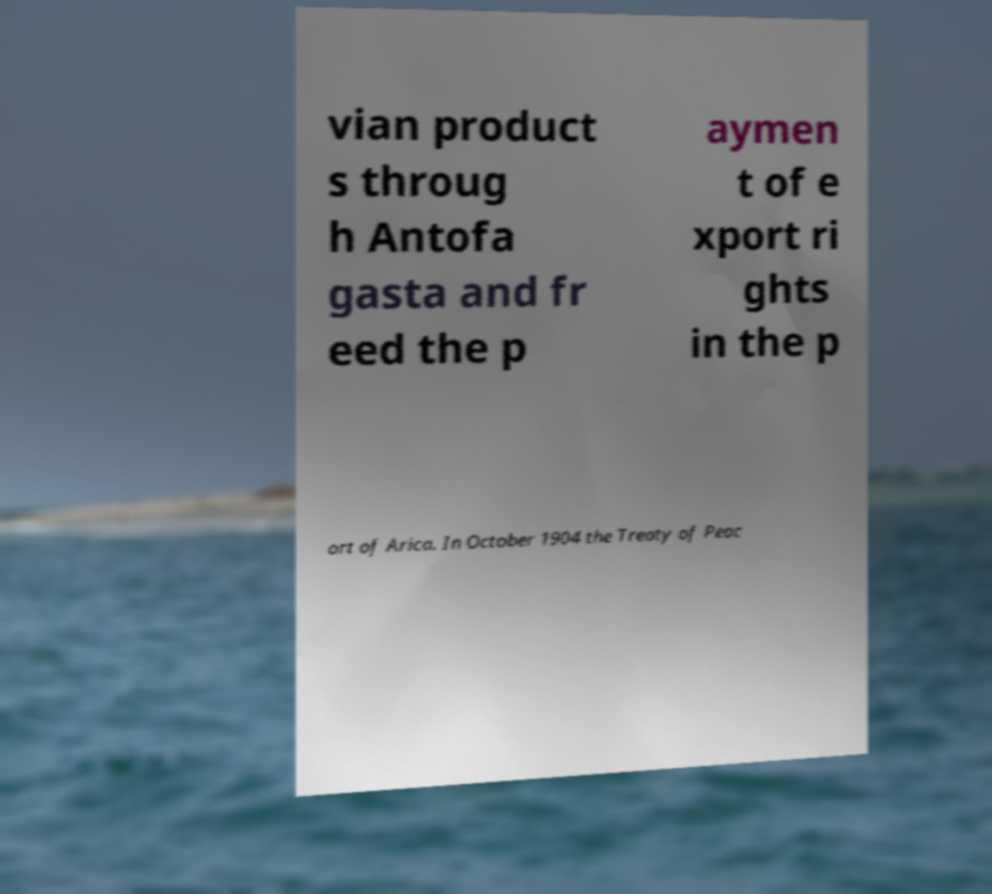What messages or text are displayed in this image? I need them in a readable, typed format. vian product s throug h Antofa gasta and fr eed the p aymen t of e xport ri ghts in the p ort of Arica. In October 1904 the Treaty of Peac 